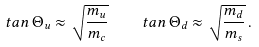<formula> <loc_0><loc_0><loc_500><loc_500>t a n \, \Theta _ { u } \approx \sqrt { \frac { m _ { u } } { m _ { c } } } \quad t a n \, \Theta _ { d } \approx \sqrt { \frac { m _ { d } } { m _ { s } } } \, .</formula> 